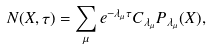Convert formula to latex. <formula><loc_0><loc_0><loc_500><loc_500>N ( X , \tau ) = \sum _ { \mu } e ^ { - \lambda _ { \mu } \tau } C _ { \lambda _ { \mu } } P _ { \lambda _ { \mu } } ( X ) ,</formula> 